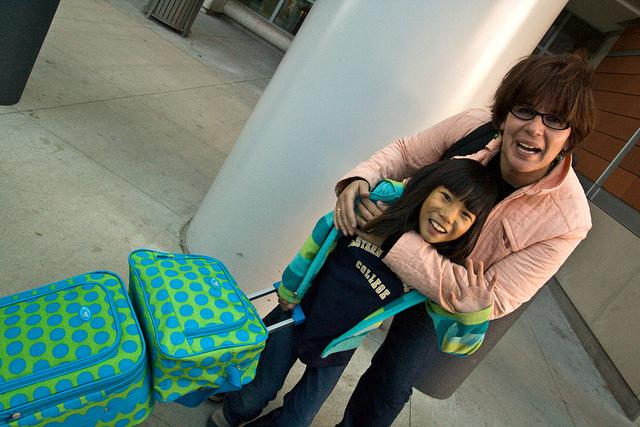Why is the young girl holding luggage? travel 